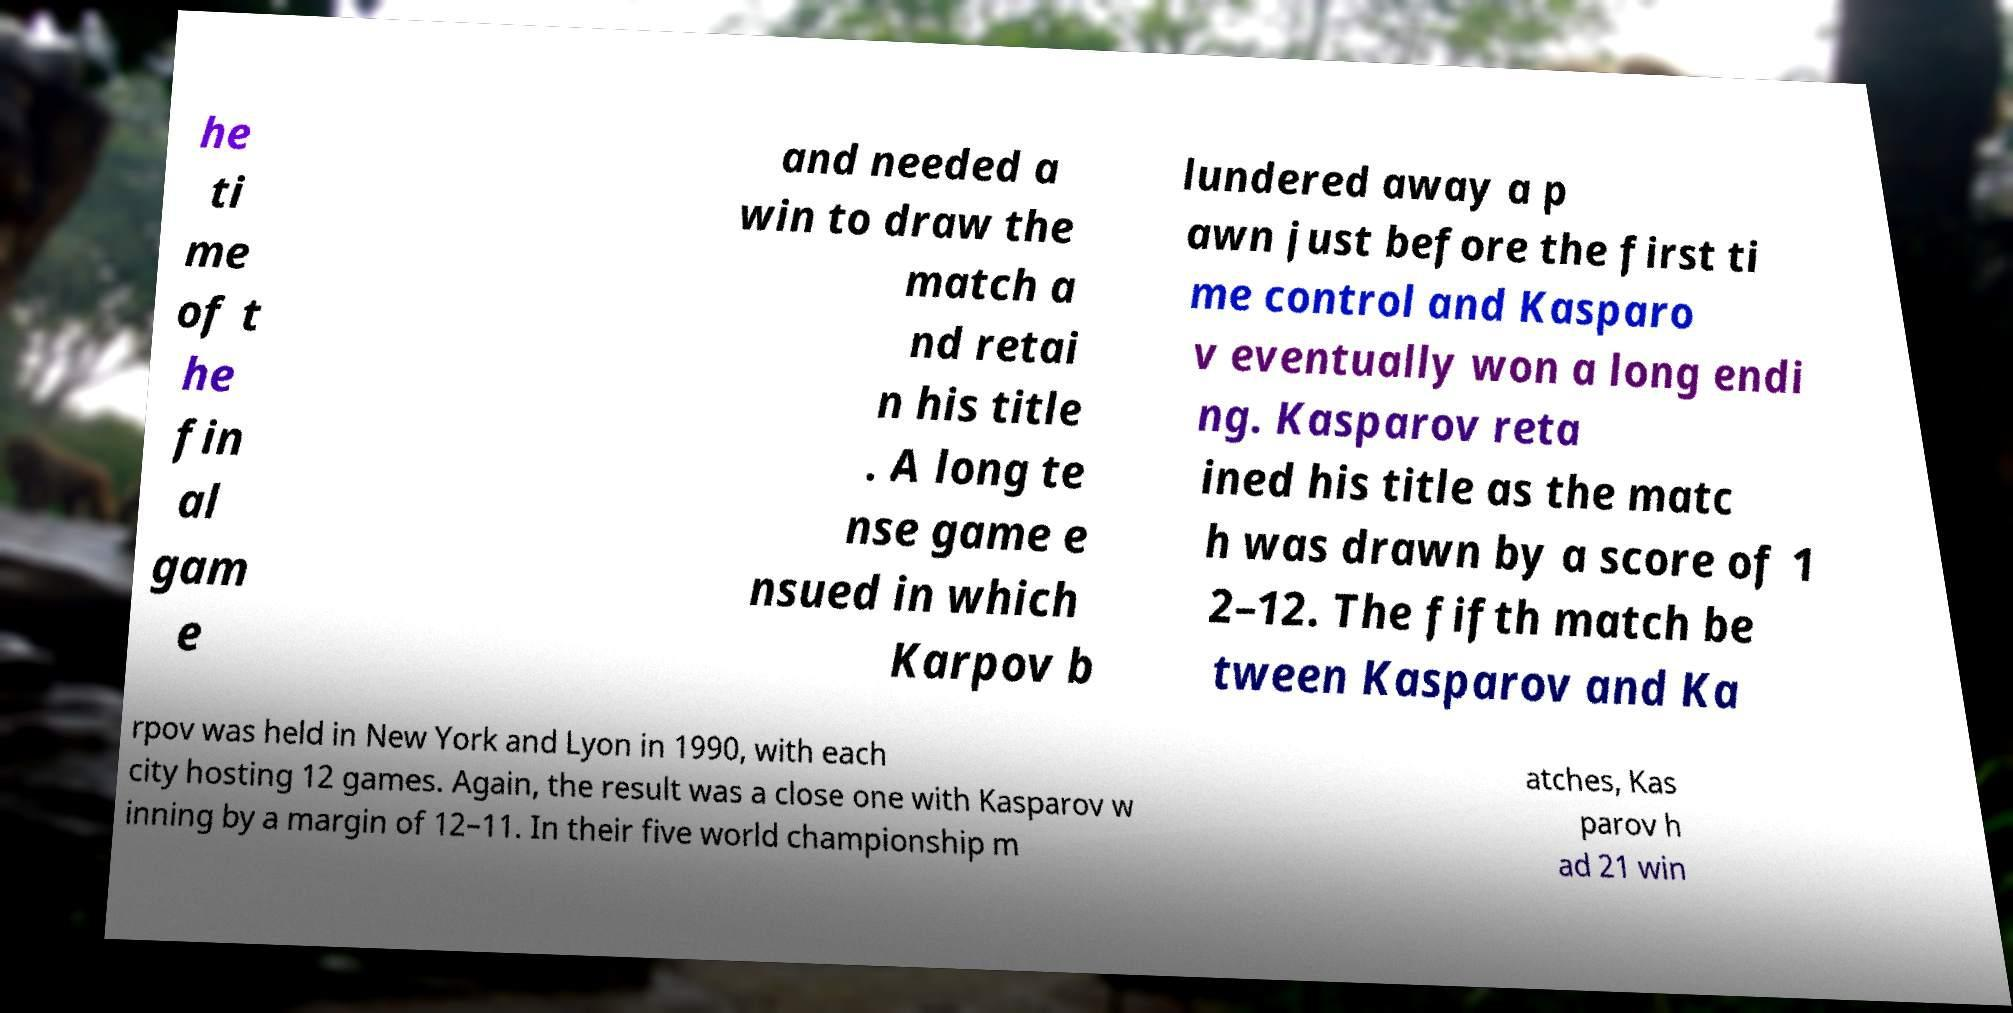Please identify and transcribe the text found in this image. he ti me of t he fin al gam e and needed a win to draw the match a nd retai n his title . A long te nse game e nsued in which Karpov b lundered away a p awn just before the first ti me control and Kasparo v eventually won a long endi ng. Kasparov reta ined his title as the matc h was drawn by a score of 1 2–12. The fifth match be tween Kasparov and Ka rpov was held in New York and Lyon in 1990, with each city hosting 12 games. Again, the result was a close one with Kasparov w inning by a margin of 12–11. In their five world championship m atches, Kas parov h ad 21 win 